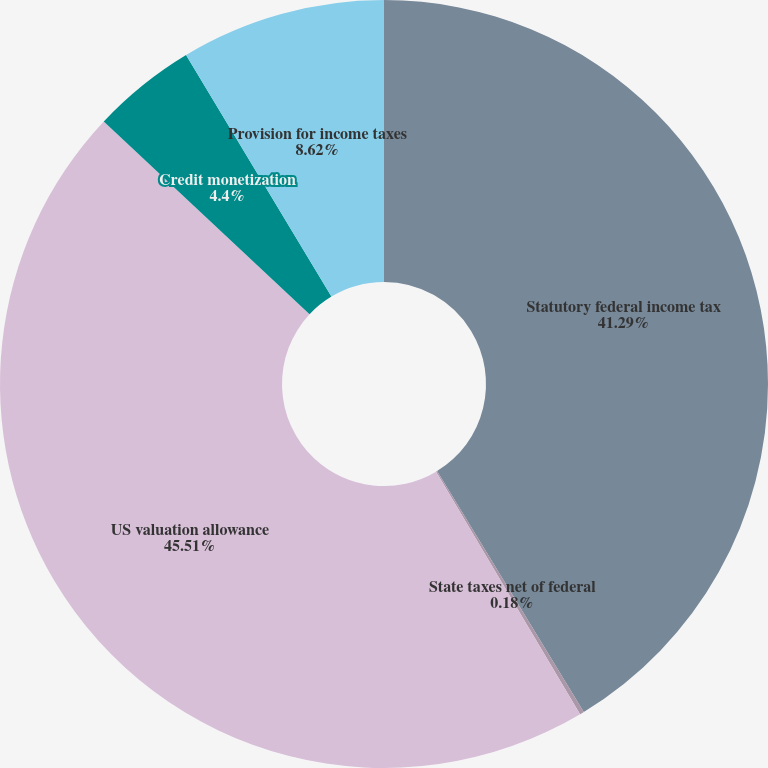<chart> <loc_0><loc_0><loc_500><loc_500><pie_chart><fcel>Statutory federal income tax<fcel>State taxes net of federal<fcel>US valuation allowance<fcel>Credit monetization<fcel>Provision for income taxes<nl><fcel>41.29%<fcel>0.18%<fcel>45.51%<fcel>4.4%<fcel>8.62%<nl></chart> 